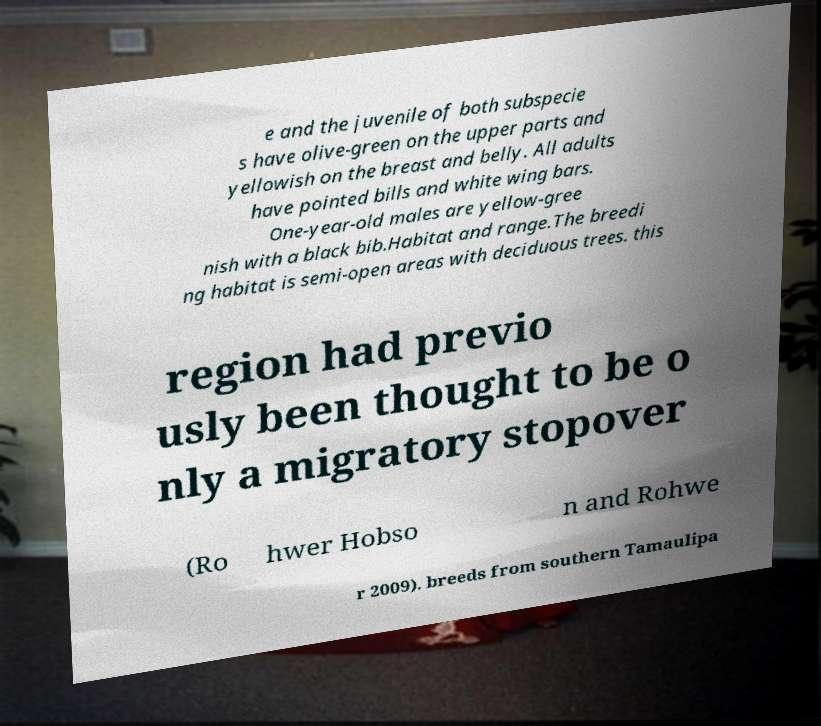For documentation purposes, I need the text within this image transcribed. Could you provide that? e and the juvenile of both subspecie s have olive-green on the upper parts and yellowish on the breast and belly. All adults have pointed bills and white wing bars. One-year-old males are yellow-gree nish with a black bib.Habitat and range.The breedi ng habitat is semi-open areas with deciduous trees. this region had previo usly been thought to be o nly a migratory stopover (Ro hwer Hobso n and Rohwe r 2009). breeds from southern Tamaulipa 